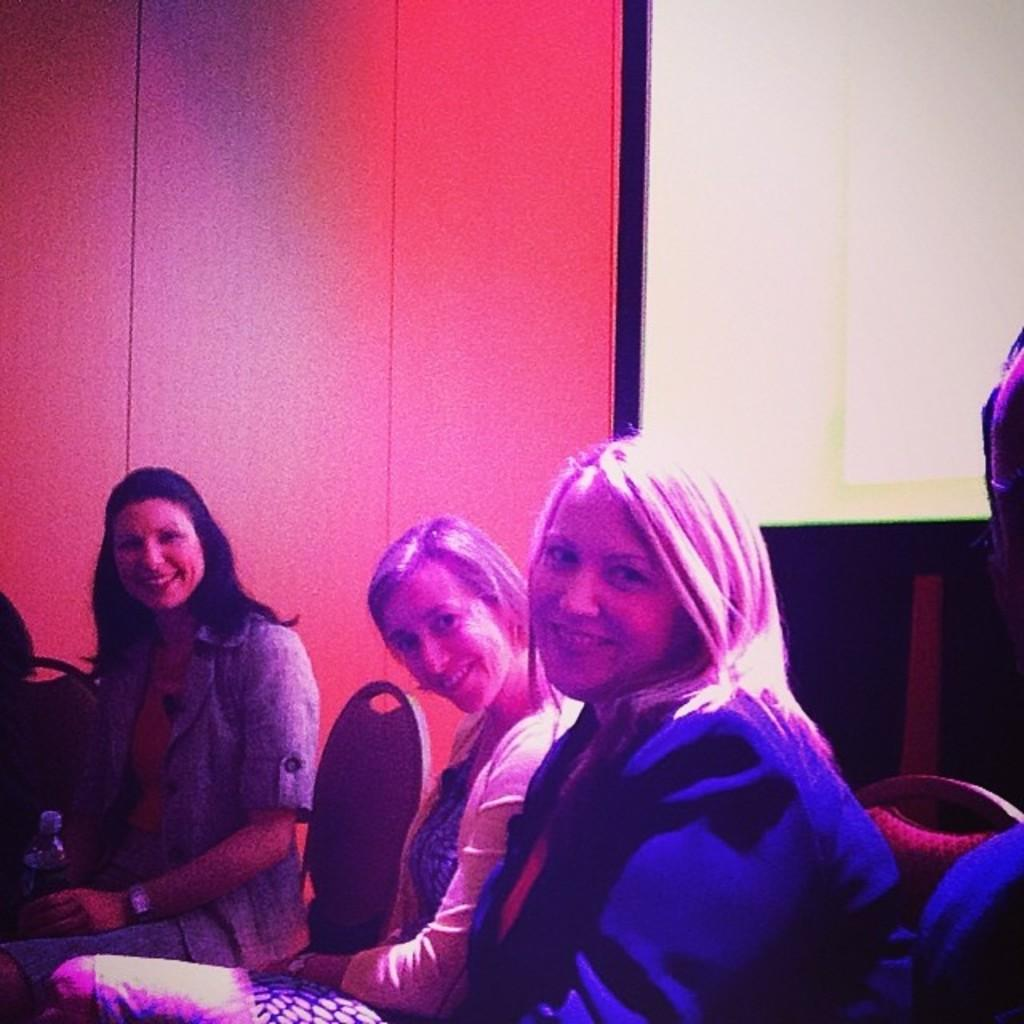Who is present in the image? There are women in the image. What are the women doing in the image? The women are sitting on chairs. What can be seen in the background of the image? There is a wall visible in the background of the image. What type of beds can be seen in the image? There are no beds present in the image; it features women sitting on chairs. What discovery was made by the women in the image? The image does not depict any discovery made by the women. 